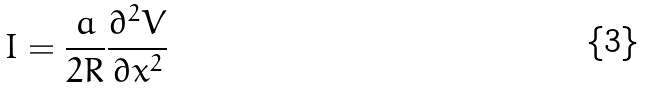Convert formula to latex. <formula><loc_0><loc_0><loc_500><loc_500>I = \frac { a } { 2 R } \frac { \partial ^ { 2 } V } { \partial x ^ { 2 } }</formula> 